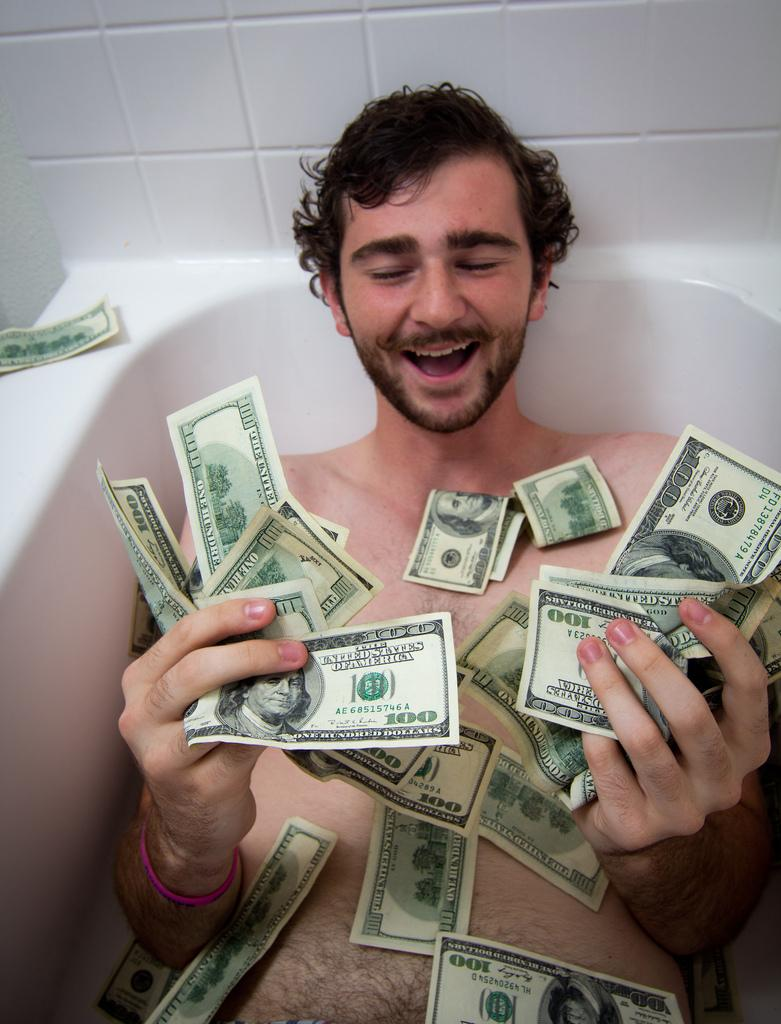What is the man doing in the image? The man is lying in a bathing tub in the image. What is the man holding in the image? The man is holding currency notes in the image. Are there any other currency notes visible in the image? Yes, there are currency notes around the man in the image. What can be seen in the background of the image? There is a wall visible in the image. What is the rate of the earth's rotation in the image? The rate of the earth's rotation is not mentioned or depicted in the image, as it is focused on the man and the currency notes. 